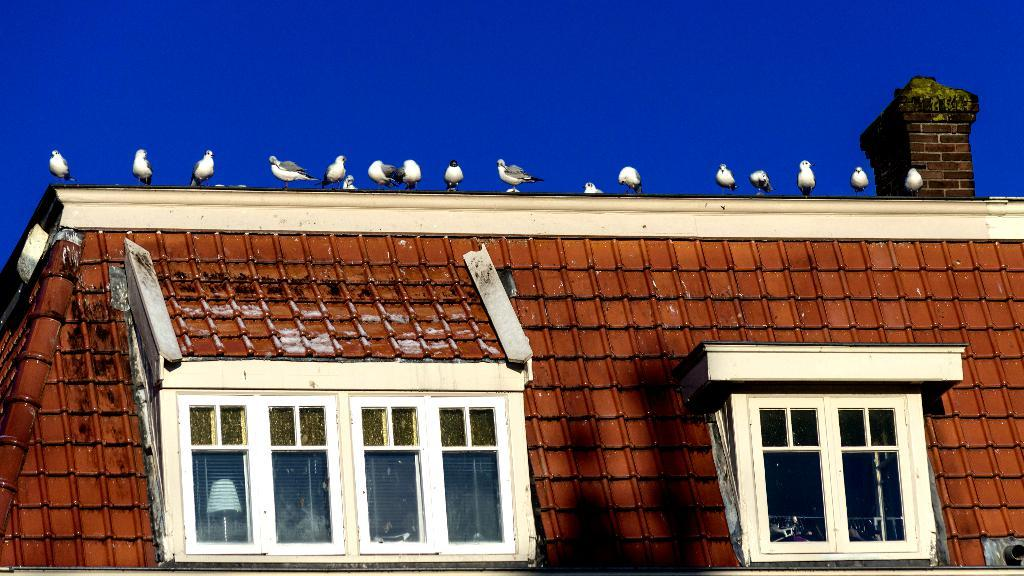What structure is present in the image? There is a building in the image. What can be seen on the building? There are birds on the building. What is visible at the top of the image? The sky is visible at the top of the image. What type of pet can be seen playing with an elbow in the image? There is no pet or elbow present in the image; it features a building with birds on it. 